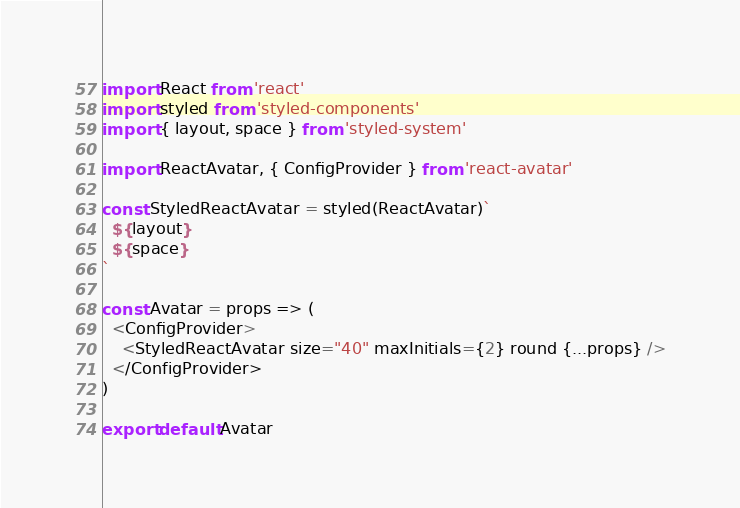Convert code to text. <code><loc_0><loc_0><loc_500><loc_500><_JavaScript_>import React from 'react'
import styled from 'styled-components'
import { layout, space } from 'styled-system'

import ReactAvatar, { ConfigProvider } from 'react-avatar'

const StyledReactAvatar = styled(ReactAvatar)`
  ${layout}
  ${space}
`

const Avatar = props => (
  <ConfigProvider>
    <StyledReactAvatar size="40" maxInitials={2} round {...props} />
  </ConfigProvider>
)

export default Avatar
</code> 